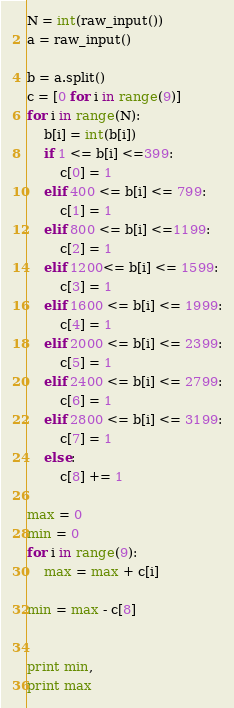<code> <loc_0><loc_0><loc_500><loc_500><_Python_>N = int(raw_input())
a = raw_input()

b = a.split()
c = [0 for i in range(9)]
for i in range(N):
	b[i] = int(b[i])
	if 1 <= b[i] <=399:
		c[0] = 1
	elif 400 <= b[i] <= 799:
		c[1] = 1
	elif 800 <= b[i] <=1199:
		c[2] = 1
	elif 1200<= b[i] <= 1599:
		c[3] = 1
	elif 1600 <= b[i] <= 1999:
		c[4] = 1
	elif 2000 <= b[i] <= 2399:
		c[5] = 1
	elif 2400 <= b[i] <= 2799:
		c[6] = 1
	elif 2800 <= b[i] <= 3199:
		c[7] = 1
	else:
		c[8] += 1

max = 0
min = 0
for i in range(9):
	max = max + c[i]

min = max - c[8]

	
print min,
print max</code> 